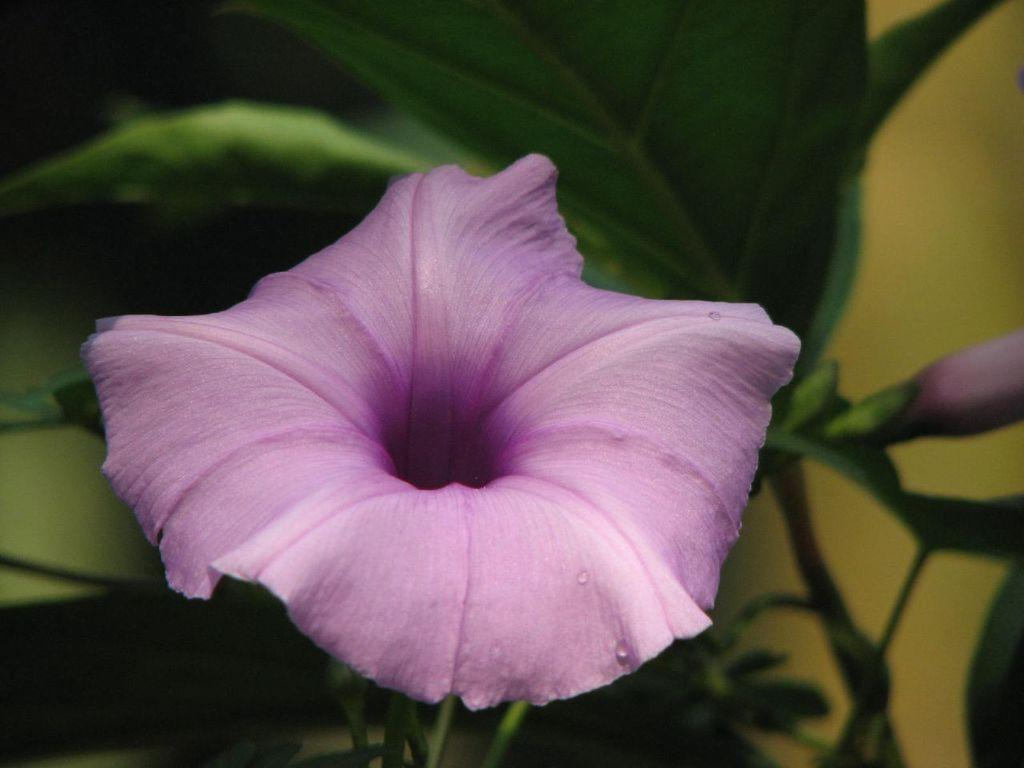What type of plant is visible in the image? There is a flower in the image. What parts of the plant can be seen besides the flower? There are stems and leaves in the image. What type of acoustics can be heard in the image? There is no sound or acoustics present in the image, as it is a still image of a flower, stems, and leaves. 